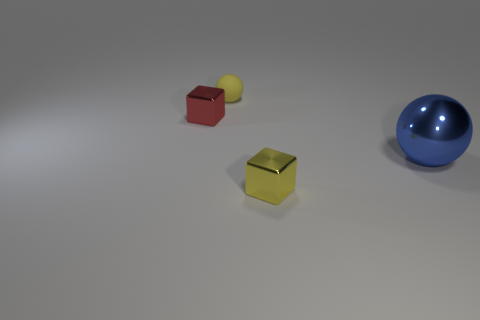Add 4 cyan cylinders. How many objects exist? 8 Subtract all yellow spheres. How many spheres are left? 1 Subtract all big metal objects. Subtract all yellow balls. How many objects are left? 2 Add 4 small matte things. How many small matte things are left? 5 Add 1 red cubes. How many red cubes exist? 2 Subtract 0 brown spheres. How many objects are left? 4 Subtract all yellow balls. Subtract all brown cylinders. How many balls are left? 1 Subtract all red cubes. How many gray balls are left? 0 